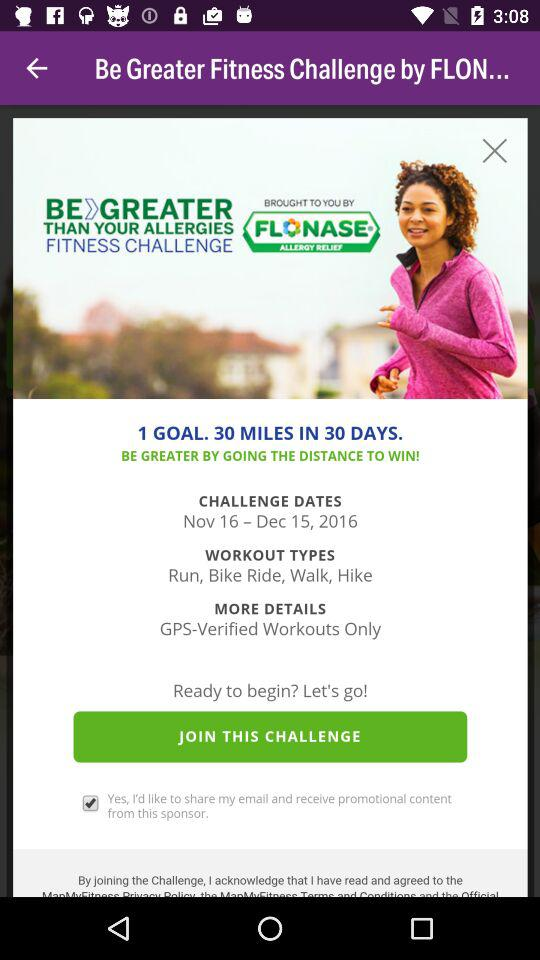What is the given goal? The given goal is "30 MILES IN 30 DAYS". 